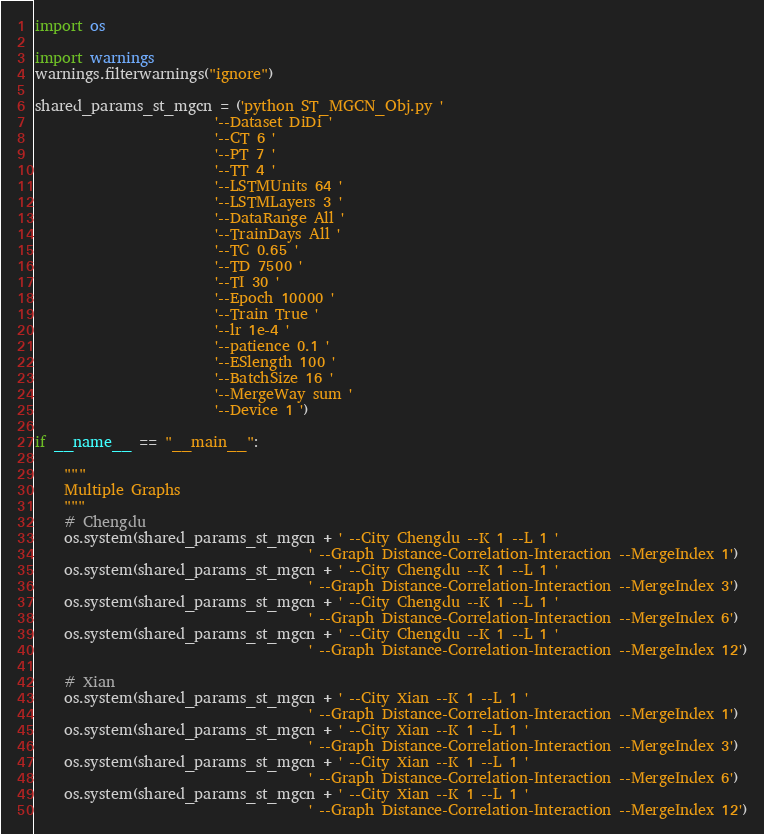<code> <loc_0><loc_0><loc_500><loc_500><_Python_>import os

import warnings
warnings.filterwarnings("ignore")

shared_params_st_mgcn = ('python ST_MGCN_Obj.py '
                         '--Dataset DiDi '
                         '--CT 6 '
                         '--PT 7 '
                         '--TT 4 '
                         '--LSTMUnits 64 '
                         '--LSTMLayers 3 '
                         '--DataRange All '
                         '--TrainDays All '
                         '--TC 0.65 '
                         '--TD 7500 '
                         '--TI 30 '
                         '--Epoch 10000 '
                         '--Train True '
                         '--lr 1e-4 '
                         '--patience 0.1 '
                         '--ESlength 100 '
                         '--BatchSize 16 '
                         '--MergeWay sum '
                         '--Device 1 ')

if __name__ == "__main__":

    """
    Multiple Graphs
    """
    # Chengdu
    os.system(shared_params_st_mgcn + ' --City Chengdu --K 1 --L 1 '
                                      ' --Graph Distance-Correlation-Interaction --MergeIndex 1')
    os.system(shared_params_st_mgcn + ' --City Chengdu --K 1 --L 1 '
                                      ' --Graph Distance-Correlation-Interaction --MergeIndex 3')
    os.system(shared_params_st_mgcn + ' --City Chengdu --K 1 --L 1 '
                                      ' --Graph Distance-Correlation-Interaction --MergeIndex 6')
    os.system(shared_params_st_mgcn + ' --City Chengdu --K 1 --L 1 '
                                      ' --Graph Distance-Correlation-Interaction --MergeIndex 12')

    # Xian
    os.system(shared_params_st_mgcn + ' --City Xian --K 1 --L 1 '
                                      ' --Graph Distance-Correlation-Interaction --MergeIndex 1')
    os.system(shared_params_st_mgcn + ' --City Xian --K 1 --L 1 '
                                      ' --Graph Distance-Correlation-Interaction --MergeIndex 3')
    os.system(shared_params_st_mgcn + ' --City Xian --K 1 --L 1 '
                                      ' --Graph Distance-Correlation-Interaction --MergeIndex 6')
    os.system(shared_params_st_mgcn + ' --City Xian --K 1 --L 1 '
                                      ' --Graph Distance-Correlation-Interaction --MergeIndex 12')
</code> 